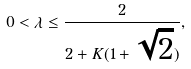<formula> <loc_0><loc_0><loc_500><loc_500>0 < \lambda \leq \frac { 2 } { 2 + K ( 1 + \sqrt { 2 } ) } ,</formula> 